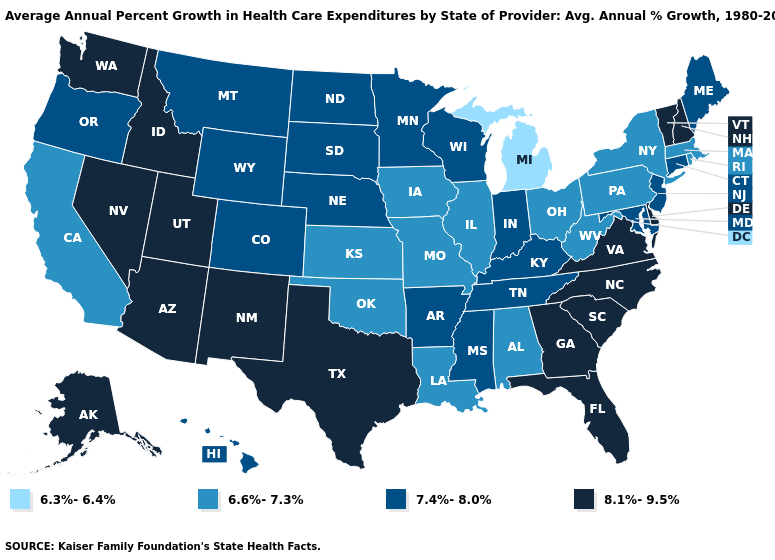Name the states that have a value in the range 7.4%-8.0%?
Concise answer only. Arkansas, Colorado, Connecticut, Hawaii, Indiana, Kentucky, Maine, Maryland, Minnesota, Mississippi, Montana, Nebraska, New Jersey, North Dakota, Oregon, South Dakota, Tennessee, Wisconsin, Wyoming. Name the states that have a value in the range 6.3%-6.4%?
Give a very brief answer. Michigan. Name the states that have a value in the range 6.6%-7.3%?
Answer briefly. Alabama, California, Illinois, Iowa, Kansas, Louisiana, Massachusetts, Missouri, New York, Ohio, Oklahoma, Pennsylvania, Rhode Island, West Virginia. What is the lowest value in the MidWest?
Give a very brief answer. 6.3%-6.4%. Does South Dakota have a lower value than Ohio?
Short answer required. No. Which states have the lowest value in the West?
Quick response, please. California. What is the lowest value in the West?
Short answer required. 6.6%-7.3%. Is the legend a continuous bar?
Be succinct. No. Does the map have missing data?
Keep it brief. No. What is the value of Florida?
Be succinct. 8.1%-9.5%. Among the states that border Utah , which have the lowest value?
Write a very short answer. Colorado, Wyoming. What is the highest value in states that border California?
Be succinct. 8.1%-9.5%. What is the value of Pennsylvania?
Short answer required. 6.6%-7.3%. Name the states that have a value in the range 6.3%-6.4%?
Be succinct. Michigan. How many symbols are there in the legend?
Concise answer only. 4. 